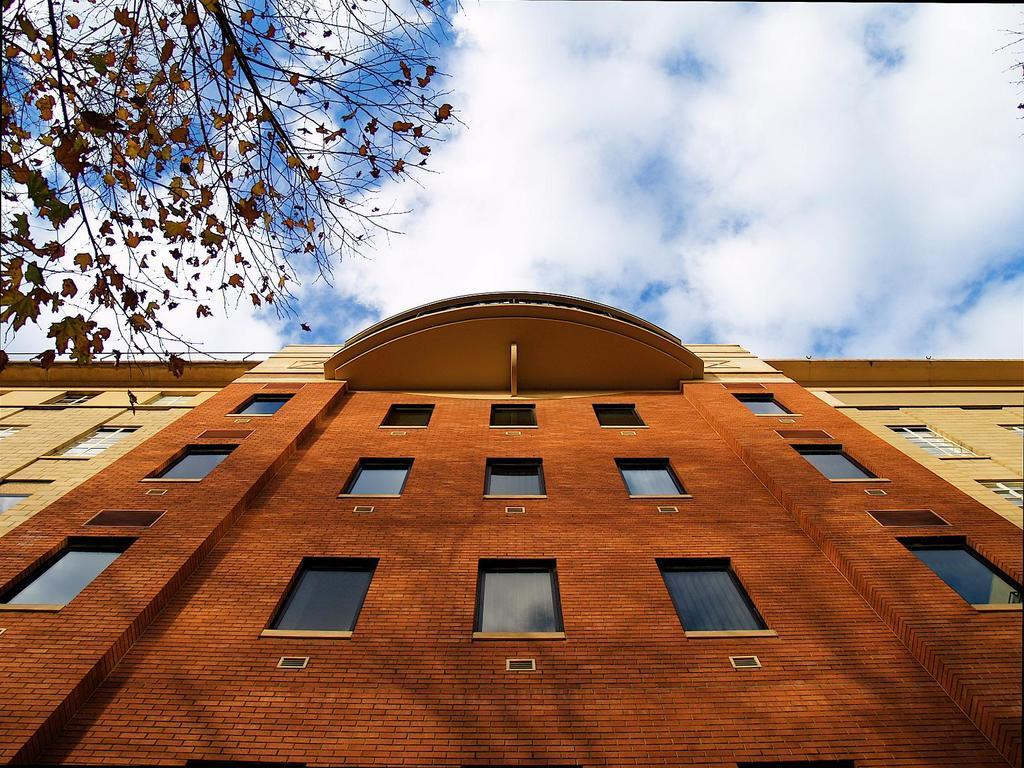What is the main structure visible in the foreground of the image? There is a building with windows in the foreground of the image. What can be seen on the left side of the image? There are tree stems on the left side of the image. What is present on the right side of the image? There are tree stems on the right side of the image. How would you describe the sky in the image? The sky is partially cloudy. How many dogs are visible in the image, and what are they doing? There are no dogs present in the image. What type of needle is being used to sew the building in the image? There is no needle or sewing activity depicted in the image; it is a photograph of a building and tree stems. 